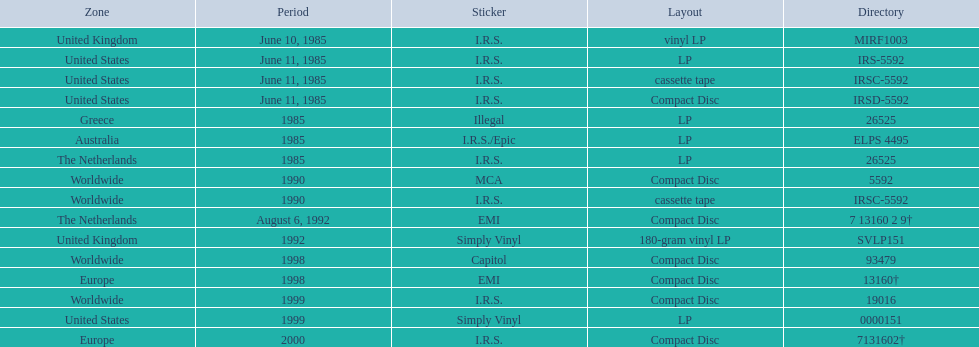What dates were lps of any kind released? June 10, 1985, June 11, 1985, 1985, 1985, 1985, 1992, 1999. In which countries were these released in by i.r.s.? United Kingdom, United States, Australia, The Netherlands. Which of these countries is not in the northern hemisphere? Australia. 